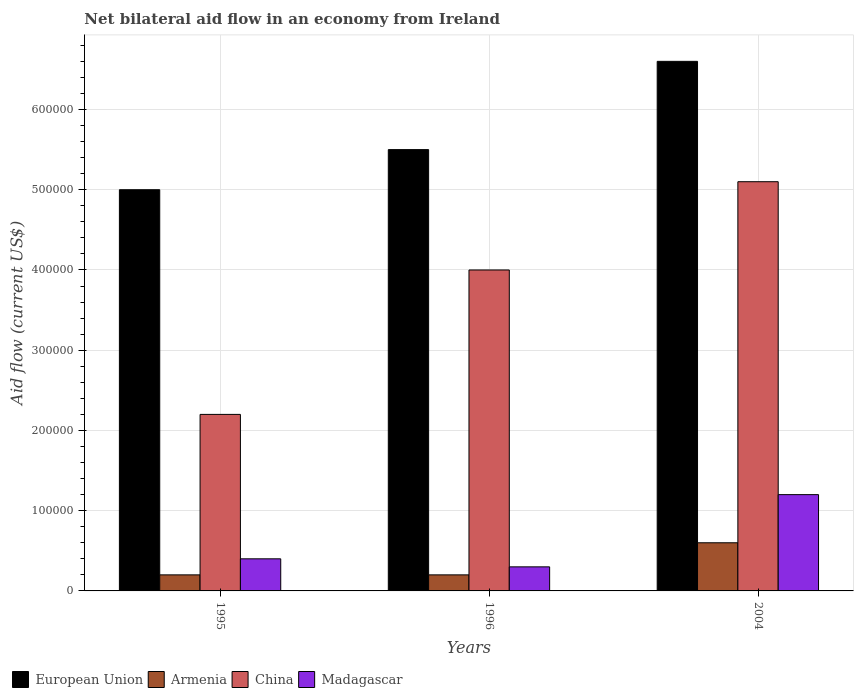How many different coloured bars are there?
Make the answer very short. 4. How many groups of bars are there?
Your response must be concise. 3. Are the number of bars per tick equal to the number of legend labels?
Your response must be concise. Yes. How many bars are there on the 1st tick from the left?
Keep it short and to the point. 4. How many bars are there on the 2nd tick from the right?
Offer a very short reply. 4. What is the net bilateral aid flow in China in 2004?
Make the answer very short. 5.10e+05. Across all years, what is the maximum net bilateral aid flow in Madagascar?
Provide a succinct answer. 1.20e+05. In which year was the net bilateral aid flow in Armenia maximum?
Provide a succinct answer. 2004. What is the total net bilateral aid flow in European Union in the graph?
Offer a very short reply. 1.71e+06. What is the difference between the net bilateral aid flow in Armenia in 1995 and that in 2004?
Make the answer very short. -4.00e+04. What is the average net bilateral aid flow in European Union per year?
Your answer should be very brief. 5.70e+05. What is the ratio of the net bilateral aid flow in European Union in 1995 to that in 1996?
Your answer should be very brief. 0.91. What is the difference between the highest and the second highest net bilateral aid flow in Armenia?
Give a very brief answer. 4.00e+04. What does the 2nd bar from the left in 1995 represents?
Give a very brief answer. Armenia. What does the 3rd bar from the right in 1996 represents?
Keep it short and to the point. Armenia. What is the difference between two consecutive major ticks on the Y-axis?
Offer a very short reply. 1.00e+05. Does the graph contain any zero values?
Your answer should be compact. No. Does the graph contain grids?
Offer a terse response. Yes. How are the legend labels stacked?
Your answer should be very brief. Horizontal. What is the title of the graph?
Ensure brevity in your answer.  Net bilateral aid flow in an economy from Ireland. What is the label or title of the X-axis?
Make the answer very short. Years. What is the label or title of the Y-axis?
Ensure brevity in your answer.  Aid flow (current US$). What is the Aid flow (current US$) in European Union in 1995?
Give a very brief answer. 5.00e+05. What is the Aid flow (current US$) of China in 1995?
Ensure brevity in your answer.  2.20e+05. What is the Aid flow (current US$) of China in 2004?
Ensure brevity in your answer.  5.10e+05. What is the Aid flow (current US$) in Madagascar in 2004?
Provide a succinct answer. 1.20e+05. Across all years, what is the maximum Aid flow (current US$) of Armenia?
Ensure brevity in your answer.  6.00e+04. Across all years, what is the maximum Aid flow (current US$) of China?
Ensure brevity in your answer.  5.10e+05. Across all years, what is the maximum Aid flow (current US$) in Madagascar?
Your response must be concise. 1.20e+05. Across all years, what is the minimum Aid flow (current US$) in Armenia?
Offer a very short reply. 2.00e+04. Across all years, what is the minimum Aid flow (current US$) in China?
Ensure brevity in your answer.  2.20e+05. What is the total Aid flow (current US$) of European Union in the graph?
Make the answer very short. 1.71e+06. What is the total Aid flow (current US$) of China in the graph?
Provide a succinct answer. 1.13e+06. What is the difference between the Aid flow (current US$) of Armenia in 1995 and that in 1996?
Offer a very short reply. 0. What is the difference between the Aid flow (current US$) in China in 1995 and that in 1996?
Make the answer very short. -1.80e+05. What is the difference between the Aid flow (current US$) in Madagascar in 1995 and that in 1996?
Keep it short and to the point. 10000. What is the difference between the Aid flow (current US$) in Madagascar in 1995 and that in 2004?
Make the answer very short. -8.00e+04. What is the difference between the Aid flow (current US$) in China in 1996 and that in 2004?
Give a very brief answer. -1.10e+05. What is the difference between the Aid flow (current US$) in Madagascar in 1996 and that in 2004?
Offer a terse response. -9.00e+04. What is the difference between the Aid flow (current US$) of European Union in 1995 and the Aid flow (current US$) of China in 1996?
Offer a terse response. 1.00e+05. What is the difference between the Aid flow (current US$) in European Union in 1995 and the Aid flow (current US$) in Madagascar in 1996?
Your answer should be very brief. 4.70e+05. What is the difference between the Aid flow (current US$) of Armenia in 1995 and the Aid flow (current US$) of China in 1996?
Your response must be concise. -3.80e+05. What is the difference between the Aid flow (current US$) in Armenia in 1995 and the Aid flow (current US$) in Madagascar in 1996?
Offer a very short reply. -10000. What is the difference between the Aid flow (current US$) of China in 1995 and the Aid flow (current US$) of Madagascar in 1996?
Your answer should be very brief. 1.90e+05. What is the difference between the Aid flow (current US$) of European Union in 1995 and the Aid flow (current US$) of Madagascar in 2004?
Offer a terse response. 3.80e+05. What is the difference between the Aid flow (current US$) of Armenia in 1995 and the Aid flow (current US$) of China in 2004?
Provide a short and direct response. -4.90e+05. What is the difference between the Aid flow (current US$) in Armenia in 1995 and the Aid flow (current US$) in Madagascar in 2004?
Offer a terse response. -1.00e+05. What is the difference between the Aid flow (current US$) in China in 1995 and the Aid flow (current US$) in Madagascar in 2004?
Offer a very short reply. 1.00e+05. What is the difference between the Aid flow (current US$) of European Union in 1996 and the Aid flow (current US$) of China in 2004?
Your response must be concise. 4.00e+04. What is the difference between the Aid flow (current US$) in Armenia in 1996 and the Aid flow (current US$) in China in 2004?
Your answer should be compact. -4.90e+05. What is the average Aid flow (current US$) in European Union per year?
Provide a succinct answer. 5.70e+05. What is the average Aid flow (current US$) of Armenia per year?
Provide a short and direct response. 3.33e+04. What is the average Aid flow (current US$) of China per year?
Ensure brevity in your answer.  3.77e+05. What is the average Aid flow (current US$) of Madagascar per year?
Offer a terse response. 6.33e+04. In the year 1995, what is the difference between the Aid flow (current US$) of European Union and Aid flow (current US$) of China?
Your answer should be very brief. 2.80e+05. In the year 1995, what is the difference between the Aid flow (current US$) of Armenia and Aid flow (current US$) of China?
Provide a succinct answer. -2.00e+05. In the year 1995, what is the difference between the Aid flow (current US$) in Armenia and Aid flow (current US$) in Madagascar?
Give a very brief answer. -2.00e+04. In the year 1995, what is the difference between the Aid flow (current US$) of China and Aid flow (current US$) of Madagascar?
Make the answer very short. 1.80e+05. In the year 1996, what is the difference between the Aid flow (current US$) of European Union and Aid flow (current US$) of Armenia?
Your answer should be very brief. 5.30e+05. In the year 1996, what is the difference between the Aid flow (current US$) in European Union and Aid flow (current US$) in China?
Offer a terse response. 1.50e+05. In the year 1996, what is the difference between the Aid flow (current US$) of European Union and Aid flow (current US$) of Madagascar?
Keep it short and to the point. 5.20e+05. In the year 1996, what is the difference between the Aid flow (current US$) of Armenia and Aid flow (current US$) of China?
Give a very brief answer. -3.80e+05. In the year 1996, what is the difference between the Aid flow (current US$) in Armenia and Aid flow (current US$) in Madagascar?
Offer a terse response. -10000. In the year 1996, what is the difference between the Aid flow (current US$) of China and Aid flow (current US$) of Madagascar?
Your answer should be very brief. 3.70e+05. In the year 2004, what is the difference between the Aid flow (current US$) in European Union and Aid flow (current US$) in Armenia?
Keep it short and to the point. 6.00e+05. In the year 2004, what is the difference between the Aid flow (current US$) in European Union and Aid flow (current US$) in Madagascar?
Provide a succinct answer. 5.40e+05. In the year 2004, what is the difference between the Aid flow (current US$) of Armenia and Aid flow (current US$) of China?
Make the answer very short. -4.50e+05. In the year 2004, what is the difference between the Aid flow (current US$) in Armenia and Aid flow (current US$) in Madagascar?
Give a very brief answer. -6.00e+04. In the year 2004, what is the difference between the Aid flow (current US$) of China and Aid flow (current US$) of Madagascar?
Provide a short and direct response. 3.90e+05. What is the ratio of the Aid flow (current US$) of European Union in 1995 to that in 1996?
Provide a succinct answer. 0.91. What is the ratio of the Aid flow (current US$) of China in 1995 to that in 1996?
Your response must be concise. 0.55. What is the ratio of the Aid flow (current US$) of European Union in 1995 to that in 2004?
Your answer should be compact. 0.76. What is the ratio of the Aid flow (current US$) in China in 1995 to that in 2004?
Make the answer very short. 0.43. What is the ratio of the Aid flow (current US$) of European Union in 1996 to that in 2004?
Your answer should be compact. 0.83. What is the ratio of the Aid flow (current US$) of China in 1996 to that in 2004?
Provide a short and direct response. 0.78. What is the ratio of the Aid flow (current US$) of Madagascar in 1996 to that in 2004?
Provide a short and direct response. 0.25. What is the difference between the highest and the second highest Aid flow (current US$) of Armenia?
Offer a very short reply. 4.00e+04. What is the difference between the highest and the second highest Aid flow (current US$) in China?
Your answer should be compact. 1.10e+05. What is the difference between the highest and the second highest Aid flow (current US$) in Madagascar?
Ensure brevity in your answer.  8.00e+04. What is the difference between the highest and the lowest Aid flow (current US$) of Armenia?
Make the answer very short. 4.00e+04. What is the difference between the highest and the lowest Aid flow (current US$) of China?
Make the answer very short. 2.90e+05. What is the difference between the highest and the lowest Aid flow (current US$) in Madagascar?
Your answer should be compact. 9.00e+04. 